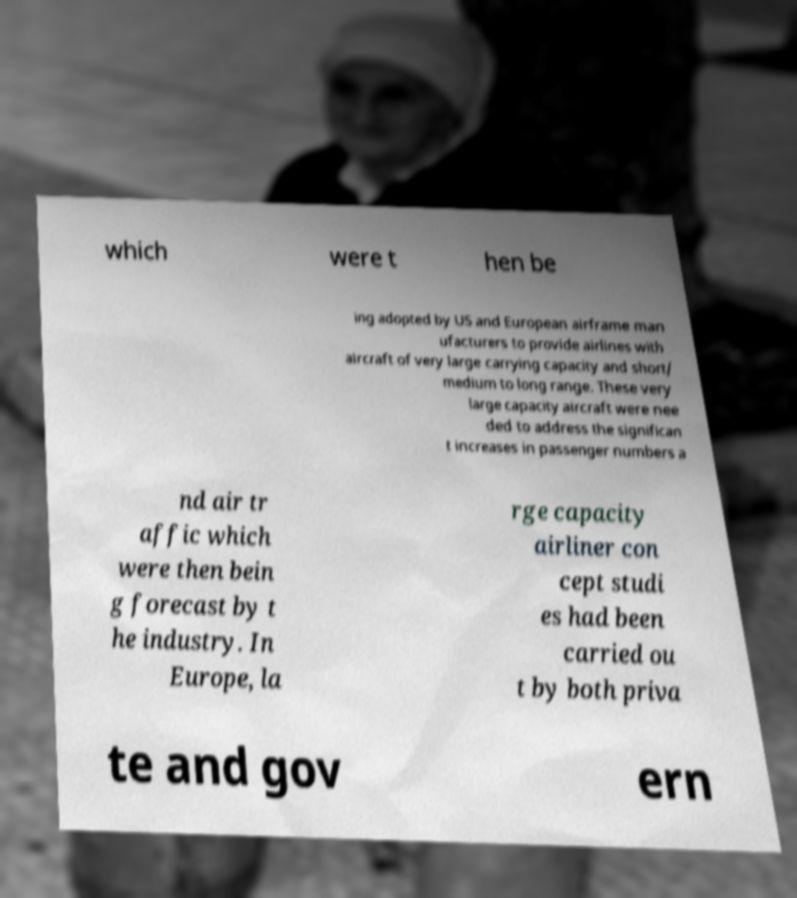Could you extract and type out the text from this image? which were t hen be ing adopted by US and European airframe man ufacturers to provide airlines with aircraft of very large carrying capacity and short/ medium to long range. These very large capacity aircraft were nee ded to address the significan t increases in passenger numbers a nd air tr affic which were then bein g forecast by t he industry. In Europe, la rge capacity airliner con cept studi es had been carried ou t by both priva te and gov ern 